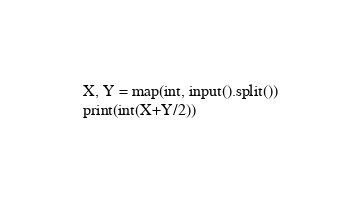<code> <loc_0><loc_0><loc_500><loc_500><_Python_>X, Y = map(int, input().split())
print(int(X+Y/2))
</code> 